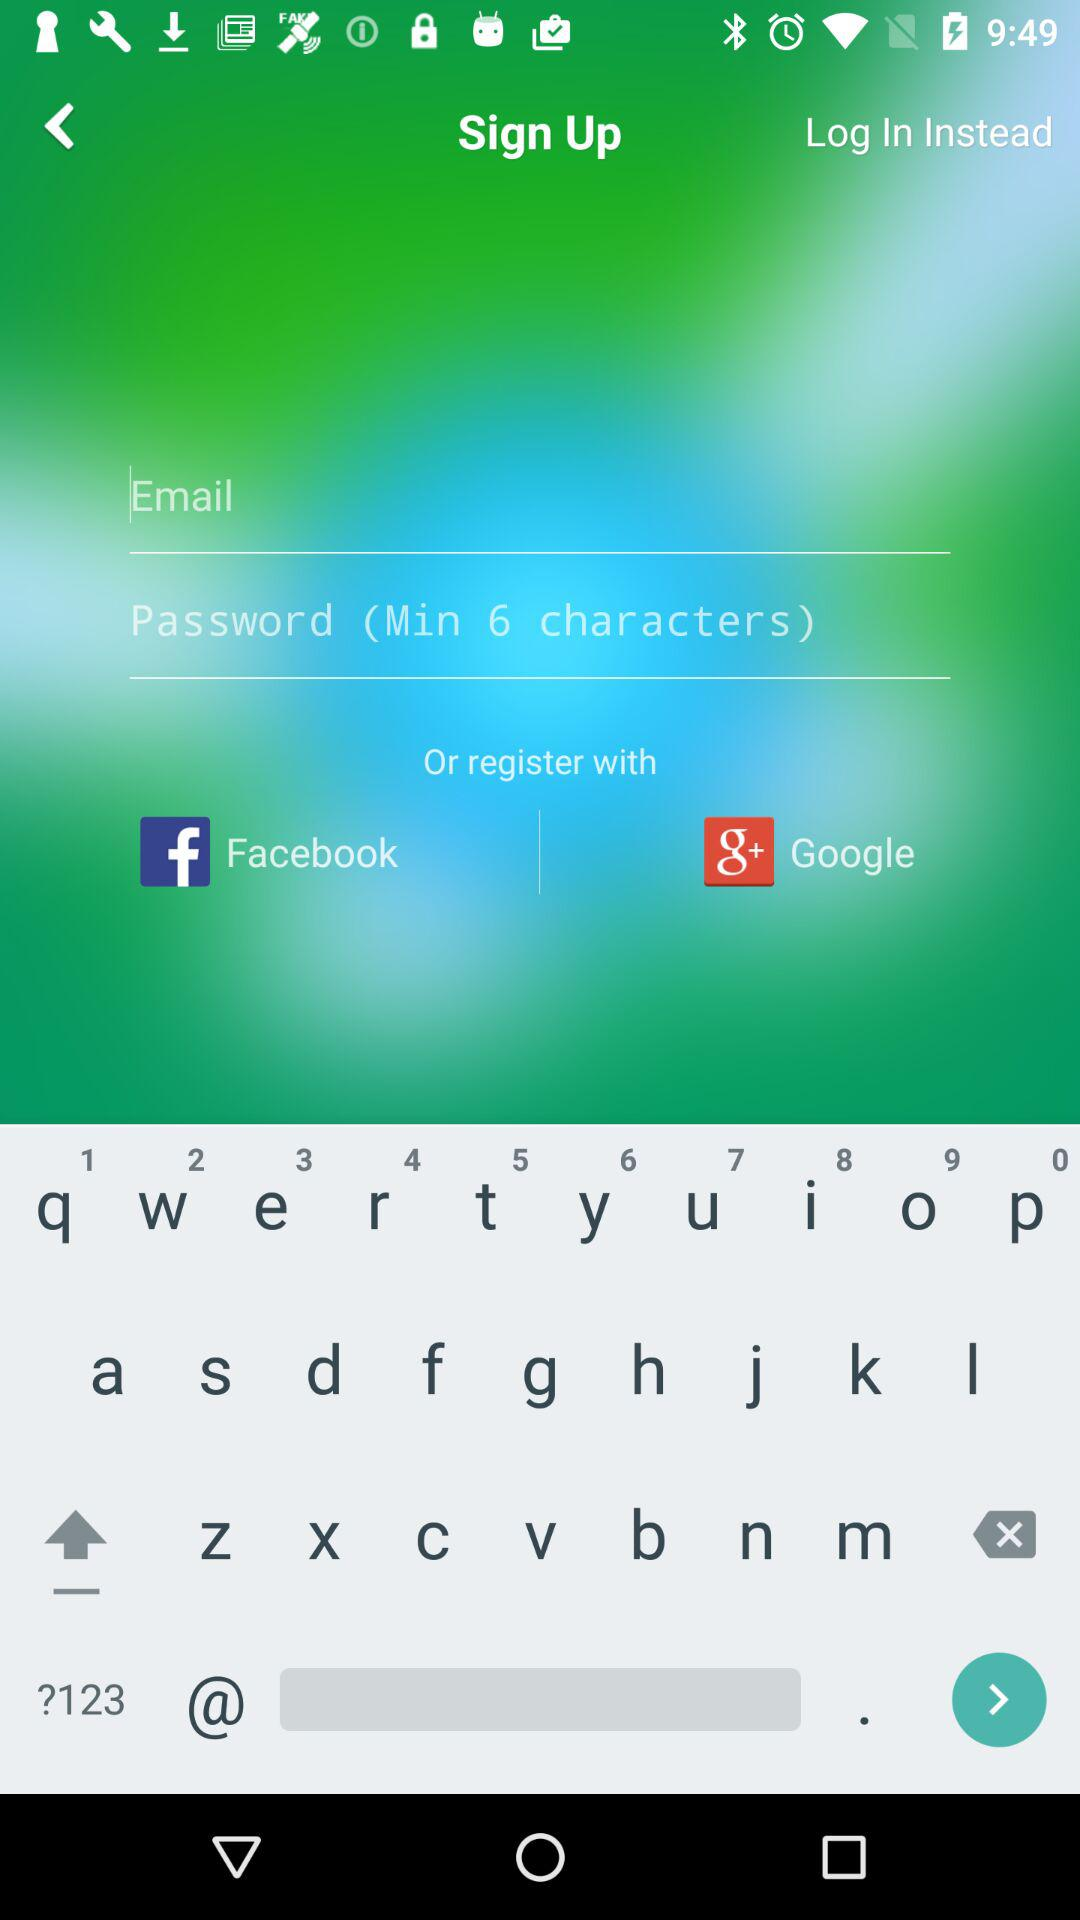What application is asking for permission? The application asking for permission is "Zelda". 